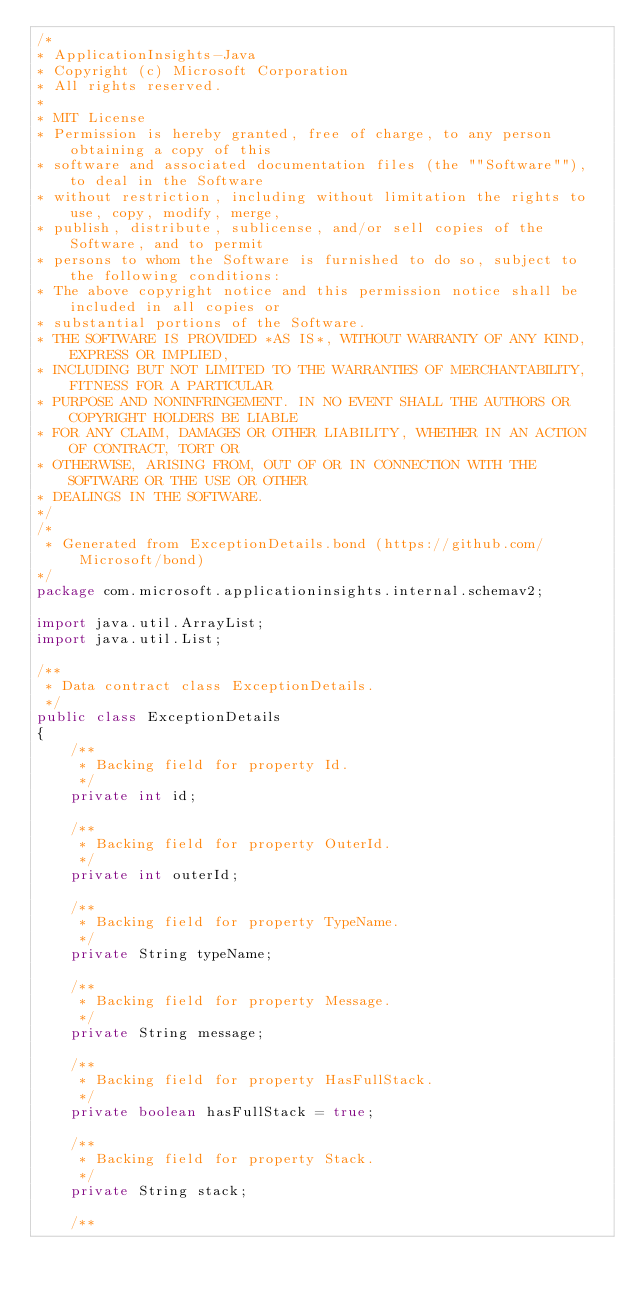Convert code to text. <code><loc_0><loc_0><loc_500><loc_500><_Java_>/*
* ApplicationInsights-Java
* Copyright (c) Microsoft Corporation
* All rights reserved.
*
* MIT License
* Permission is hereby granted, free of charge, to any person obtaining a copy of this
* software and associated documentation files (the ""Software""), to deal in the Software
* without restriction, including without limitation the rights to use, copy, modify, merge,
* publish, distribute, sublicense, and/or sell copies of the Software, and to permit
* persons to whom the Software is furnished to do so, subject to the following conditions:
* The above copyright notice and this permission notice shall be included in all copies or
* substantial portions of the Software.
* THE SOFTWARE IS PROVIDED *AS IS*, WITHOUT WARRANTY OF ANY KIND, EXPRESS OR IMPLIED,
* INCLUDING BUT NOT LIMITED TO THE WARRANTIES OF MERCHANTABILITY, FITNESS FOR A PARTICULAR
* PURPOSE AND NONINFRINGEMENT. IN NO EVENT SHALL THE AUTHORS OR COPYRIGHT HOLDERS BE LIABLE
* FOR ANY CLAIM, DAMAGES OR OTHER LIABILITY, WHETHER IN AN ACTION OF CONTRACT, TORT OR
* OTHERWISE, ARISING FROM, OUT OF OR IN CONNECTION WITH THE SOFTWARE OR THE USE OR OTHER
* DEALINGS IN THE SOFTWARE.
*/
/*
 * Generated from ExceptionDetails.bond (https://github.com/Microsoft/bond)
*/
package com.microsoft.applicationinsights.internal.schemav2;

import java.util.ArrayList;
import java.util.List;

/**
 * Data contract class ExceptionDetails.
 */
public class ExceptionDetails
{
    /**
     * Backing field for property Id.
     */
    private int id;

    /**
     * Backing field for property OuterId.
     */
    private int outerId;

    /**
     * Backing field for property TypeName.
     */
    private String typeName;

    /**
     * Backing field for property Message.
     */
    private String message;

    /**
     * Backing field for property HasFullStack.
     */
    private boolean hasFullStack = true;

    /**
     * Backing field for property Stack.
     */
    private String stack;

    /**</code> 